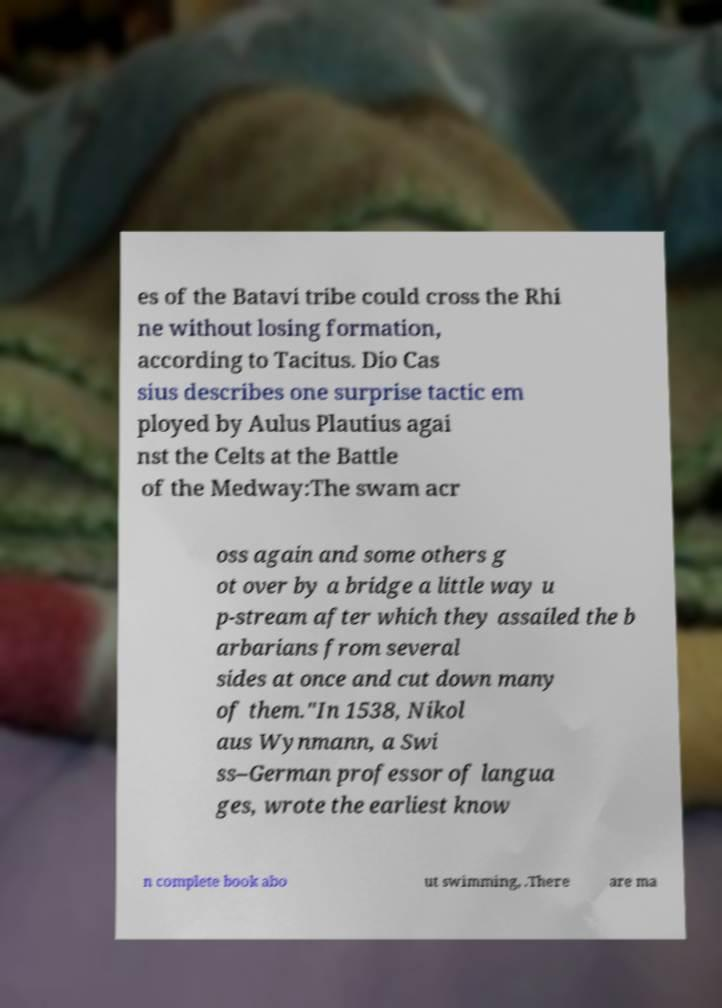Can you accurately transcribe the text from the provided image for me? es of the Batavi tribe could cross the Rhi ne without losing formation, according to Tacitus. Dio Cas sius describes one surprise tactic em ployed by Aulus Plautius agai nst the Celts at the Battle of the Medway:The swam acr oss again and some others g ot over by a bridge a little way u p-stream after which they assailed the b arbarians from several sides at once and cut down many of them."In 1538, Nikol aus Wynmann, a Swi ss–German professor of langua ges, wrote the earliest know n complete book abo ut swimming, .There are ma 